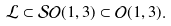Convert formula to latex. <formula><loc_0><loc_0><loc_500><loc_500>\mathcal { L } \subset \mathcal { S } \mathcal { O } ( 1 , 3 ) \subset \mathcal { O } ( 1 , 3 ) .</formula> 